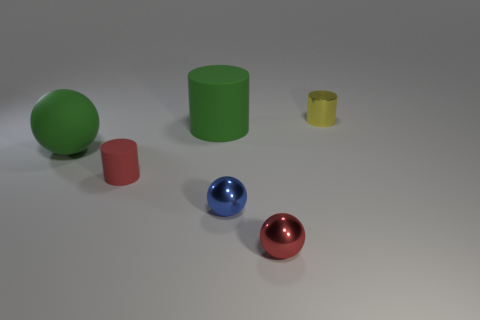Subtract all matte cylinders. How many cylinders are left? 1 Add 1 green matte things. How many objects exist? 7 Subtract all yellow spheres. Subtract all red cubes. How many spheres are left? 3 Subtract 0 cyan blocks. How many objects are left? 6 Subtract all tiny red objects. Subtract all metallic things. How many objects are left? 1 Add 5 tiny yellow things. How many tiny yellow things are left? 6 Add 6 tiny red metal spheres. How many tiny red metal spheres exist? 7 